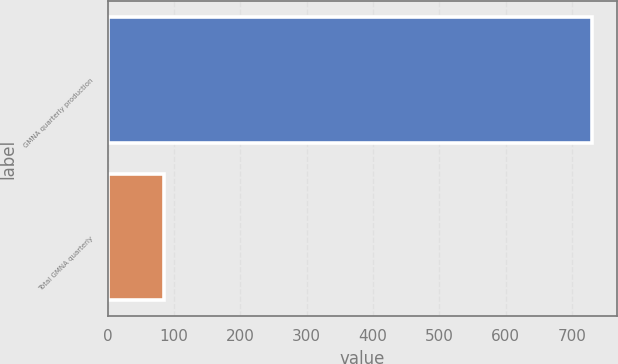Convert chart. <chart><loc_0><loc_0><loc_500><loc_500><bar_chart><fcel>GMNA quarterly production<fcel>Total GMNA quarterly<nl><fcel>731<fcel>85.1<nl></chart> 